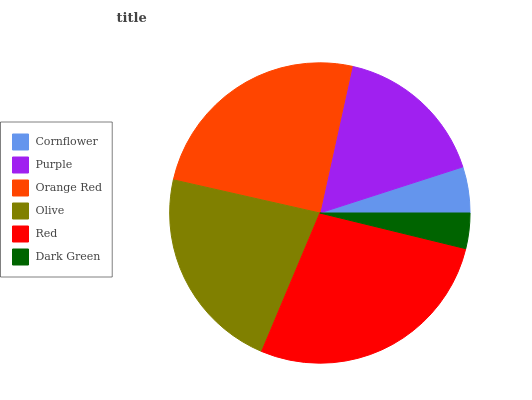Is Dark Green the minimum?
Answer yes or no. Yes. Is Red the maximum?
Answer yes or no. Yes. Is Purple the minimum?
Answer yes or no. No. Is Purple the maximum?
Answer yes or no. No. Is Purple greater than Cornflower?
Answer yes or no. Yes. Is Cornflower less than Purple?
Answer yes or no. Yes. Is Cornflower greater than Purple?
Answer yes or no. No. Is Purple less than Cornflower?
Answer yes or no. No. Is Olive the high median?
Answer yes or no. Yes. Is Purple the low median?
Answer yes or no. Yes. Is Red the high median?
Answer yes or no. No. Is Orange Red the low median?
Answer yes or no. No. 